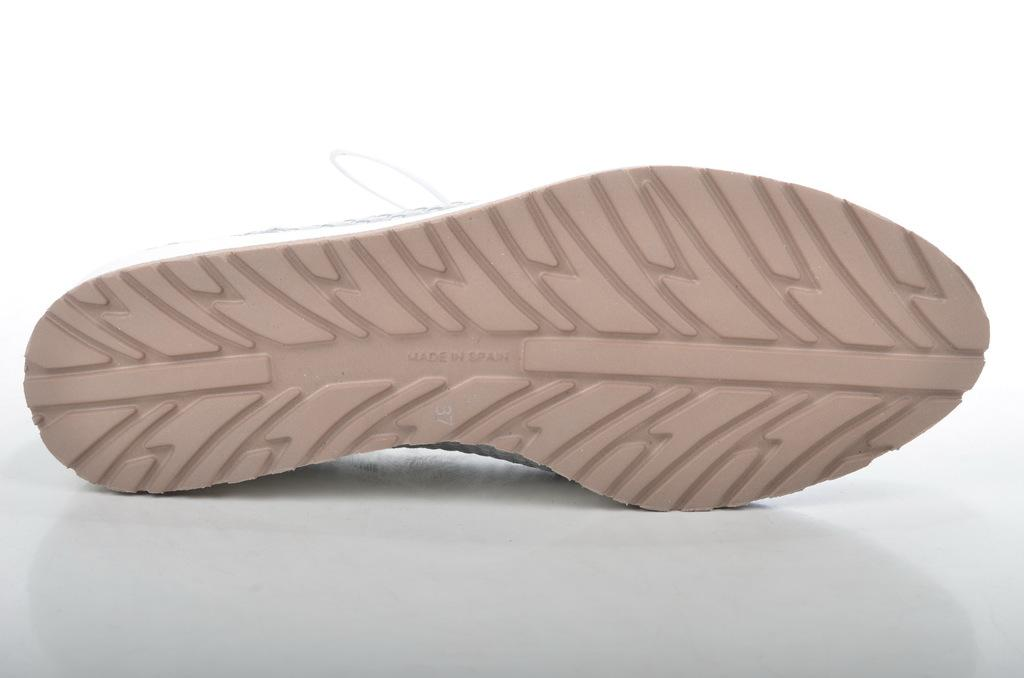What type of object is present in the image? There is footwear in the image. What type of bird can be seen flying near the volcano in the image? There is no bird or volcano present in the image; it only features footwear. 